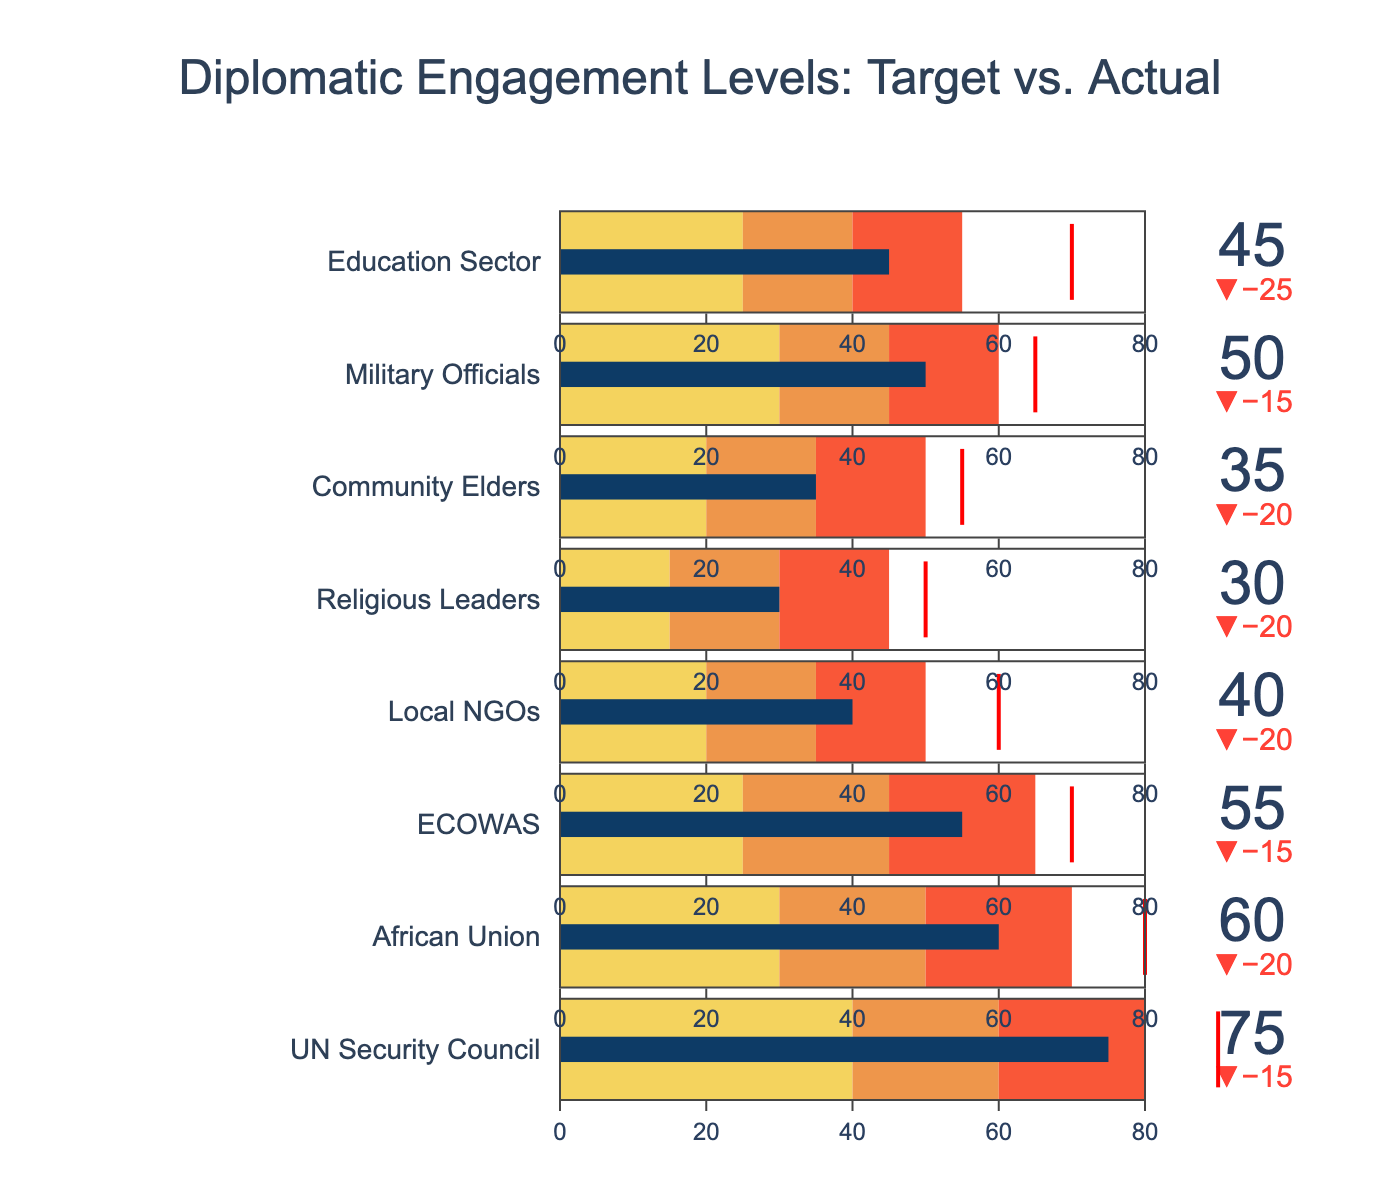How many categories are displayed in the figure? Count the number of distinct categories listed on the vertical axis of the Bullet Chart.
Answer: 8 What is the title of the figure? The title is typically displayed at the top center of the chart.
Answer: Diplomatic Engagement Levels: Target vs. Actual Which stakeholder has the highest target level of engagement? Compare the target levels of engagement for each stakeholder to identify the highest value.
Answer: UN Security Council Which stakeholder has the largest gap between actual and target engagement levels? Calculate the difference between actual and target levels for each stakeholder and find the maximum gap.
Answer: UN Security Council Which categories fall within the "poor" range for their actual engagement levels? Identify categories where the actual engagement falls within the "Range1" values.
Answer: Local NGOs, Religious Leaders, Community Elders, Education Sector Which stakeholders surpassed the "average" range but did not meet their target? Look for stakeholders whose actual engagement is within the "Range2" but below their target.
Answer: None What is the actual engagement level of African Union, and how does it compare to its target? Read the actual and target engagement levels for African Union and compare.
Answer: Actual: 60, Target: 80 Which category has the closest actual engagement level to its target? Calculate the absolute differences between actual and target for all categories and identify the smallest.
Answer: Military Officials How many categories have their actual engagement levels above 50? Count the number of categories where actual engagement is greater than 50.
Answer: 3 Are there any categories where the actual engagement level is at or above the highest range? Check if any actual engagement levels exceed the "Range3" values.
Answer: No 